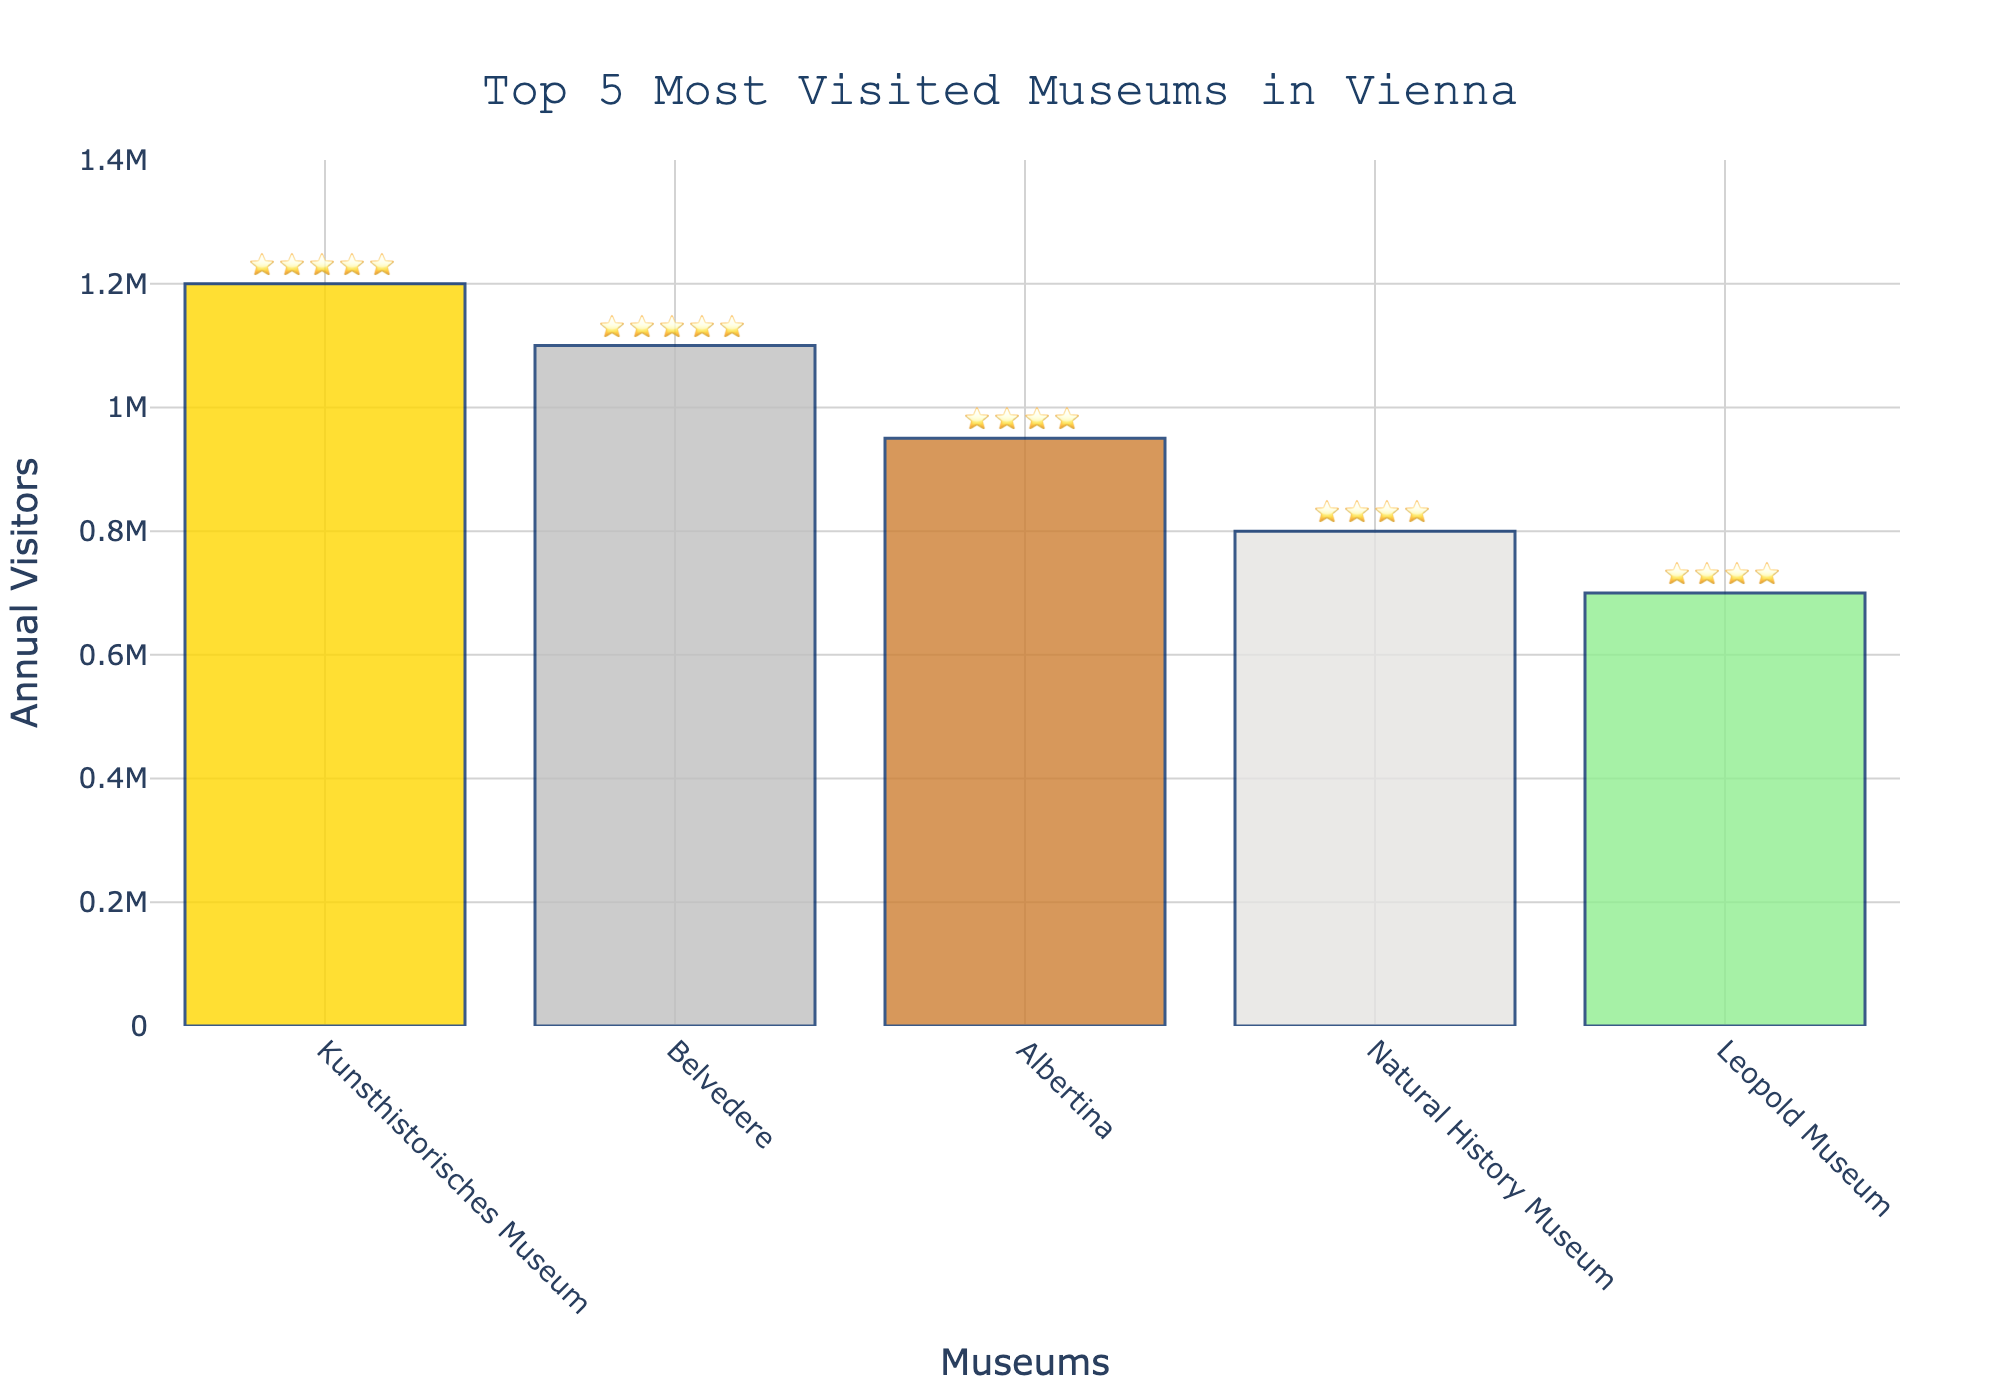Which museum has the highest number of visitors per year? The museum with the highest number of visitors is at the top of the bars in the chart. The 'Kunsthistorisches Museum' has the highest bar, indicating it has the most visitors per year.
Answer: Kunsthistorisches Museum What is the rating of the Belvedere museum? To find the rating, look at the star icons next to the name 'Belvedere' on the chart. It shows five stars, indicating a top rating.
Answer: ⭐⭐⭐⭐⭐ Which museums have a rating of four stars? Identify the museums with four-star ratings by looking at the star icons on the chart. Both the 'Albertina' and the 'Natural History Museum' have four-star ratings.
Answer: Albertina, Natural History Museum How many visitors do the top three museums receive in total per year? Add the number of visitors per year for the top three museums. Kunsthistorisches Museum (1,200,000) + Belvedere (1,100,000) + Albertina (950,000) = 3,250,000 visitors.
Answer: 3,250,000 Which museum has the lowest number of visitors per year? The bar with the shortest height represents the museum with the lowest visitors. The 'Leopold Museum' has the shortest bar, thus the least visitors per year.
Answer: Leopold Museum Between the Natural History Museum and the Leopold Museum, which one has more visitors, and by how much? The height of the bars shows that the Natural History Museum has more visitors. Calculate the difference: Natural History Museum (800,000) - Leopold Museum (700,000) = 100,000.
Answer: Natural History Museum, 100,000 What is the color of the bar representing the Albertina? Observe the color filled in the bar for 'Albertina' on the chart. It is indicated by bronze color.
Answer: Bronze If a new museum attracts 900,000 visitors per year, where would it rank among these five museums? Compare the new visitor count with the existing ones. 900,000 visitors is more than the Leopold Museum (700,000) and Natural History Museum (800,000) but less than Albertina (950,000). The new ranking would be fourth.
Answer: Fourth What is the average number of annual visitors across all five museums? Sum the number of visitors and divide by the number of museums. (1,200,000 + 1,100,000 + 950,000 + 800,000 + 700,000) / 5 = 950,000.
Answer: 950,000 Which museum has a visitor rating that does not match the others in terms of four or five stars? Examine the star ratings next to each museum. Four out of five museums have four or five stars, but three have four stars. 'Albertina' and 'Natural History Museum' have four stars, indicating their rating does not fully match the majority having five stars.
Answer: Albertina, Natural History Museum 